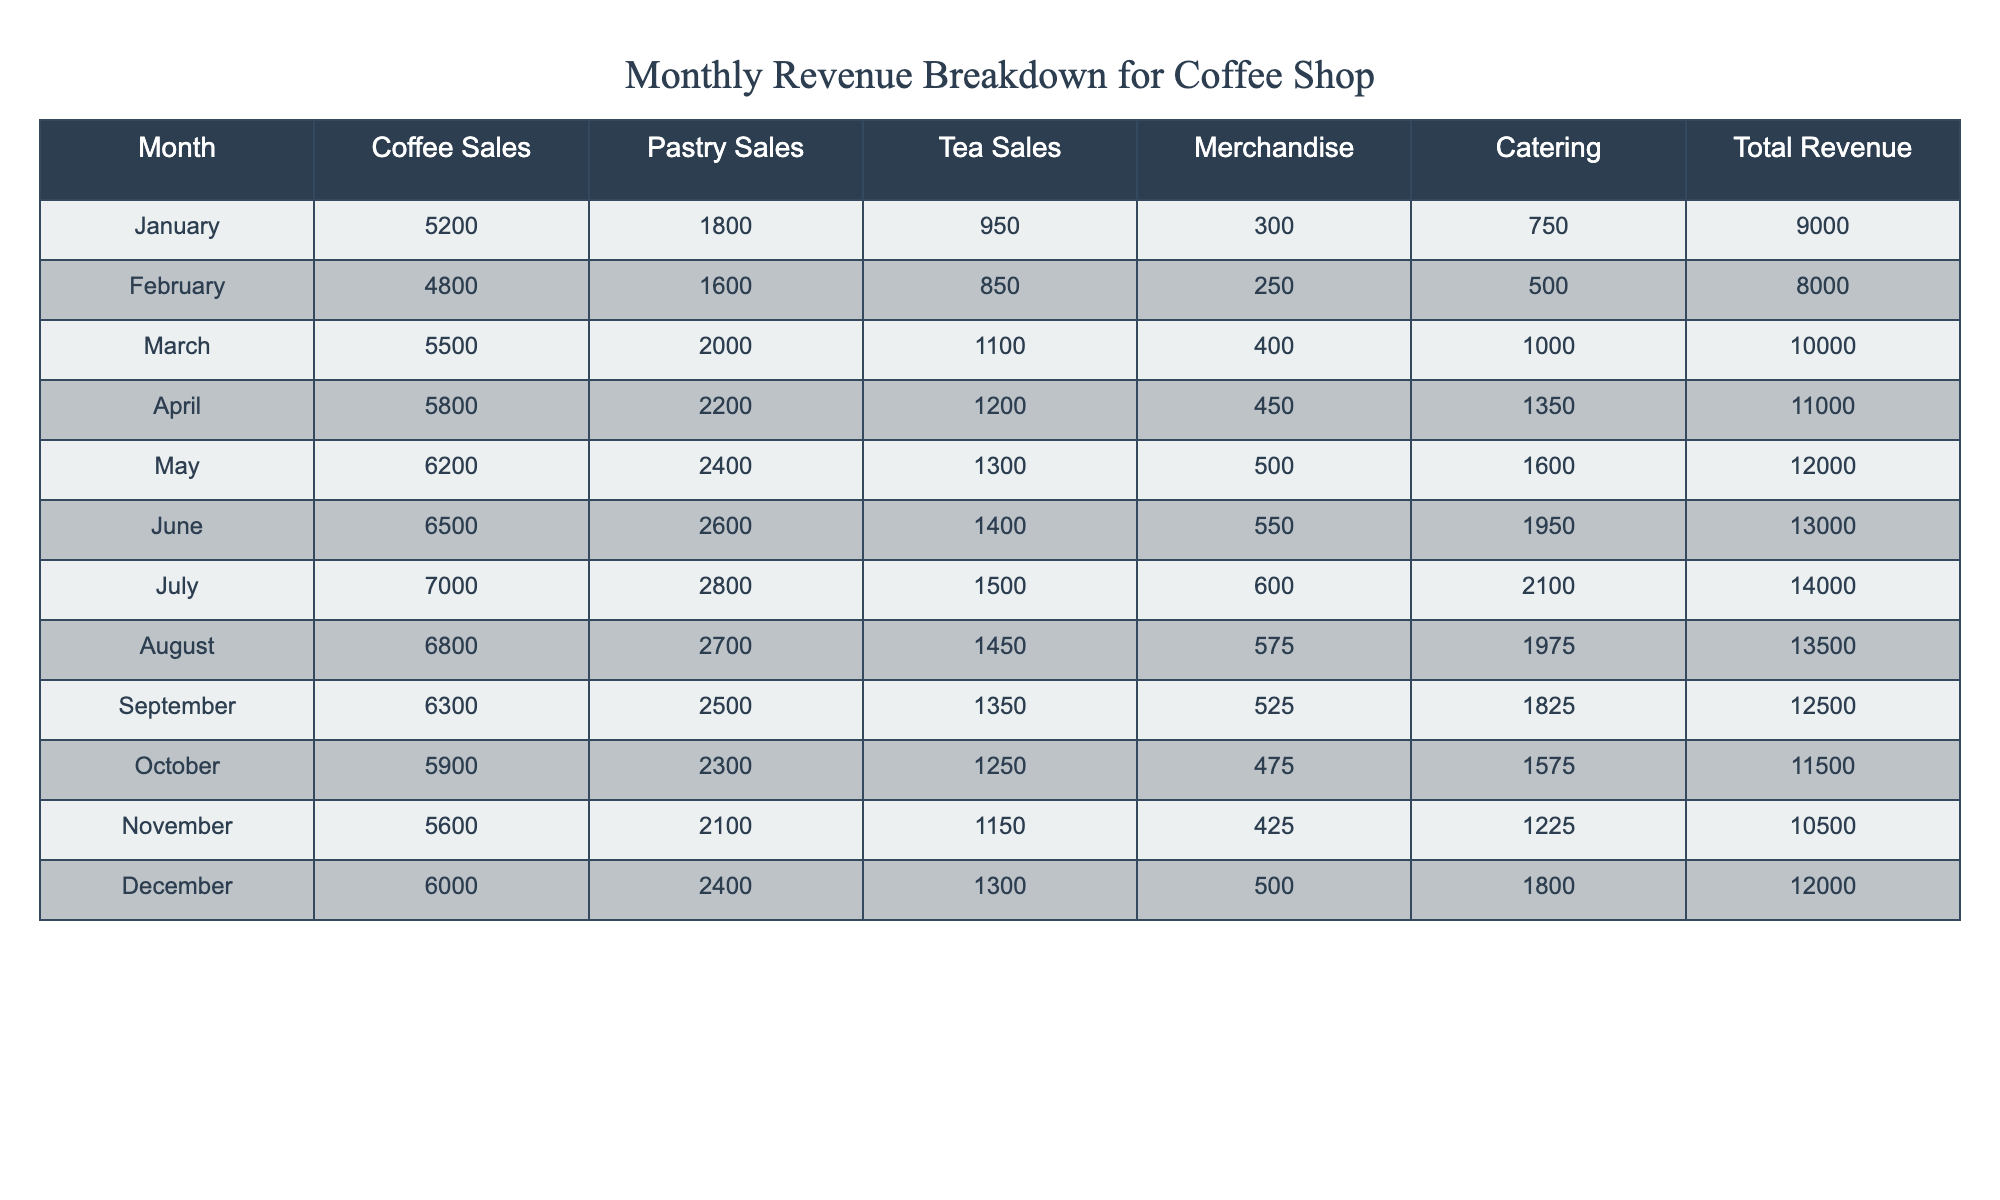What was the total revenue in July? The table shows that the total revenue for July is listed directly under the 'Total Revenue' column, which is 14,000.
Answer: 14,000 What were the coffee sales in March? The coffee sales figure for March can be found directly in the 'Coffee Sales' column under March, which is 5,500.
Answer: 5,500 Which month had the highest pastry sales? By comparing the values in the 'Pastry Sales' column, April has the highest sales at 2,200.
Answer: April What is the total revenue for the first half of the year (January to June)? To calculate this, sum the total revenues from January to June: 9,000 + 8,000 + 10,000 + 11,000 + 12,000 + 13,000 = 63,000.
Answer: 63,000 Did the coffee shop earn more in December than in January? Comparing the total revenues of December (12,000) and January (9,000), December's revenue is higher.
Answer: Yes What are the average tea sales over the year? Add the tea sales figures for each month (950 + 850 + 1,100 + 1,200 + 1,300 + 1,400 + 1,500 + 1,450 + 1,350 + 1,250 + 1,150 + 1,300 = 15,800) and divide by 12 months to get 15,800 / 12 = 1,316.67.
Answer: 1,316.67 In which month did catering sales reach 1,000 or more? By reviewing the 'Catering' column, catering sales reached 1,000 or more in March, April, May, June, July, August, and December.
Answer: Multiple months What is the difference in total revenue between June and October? Calculate the total revenue for June (13,000) and October (11,500) and find their difference: 13,000 - 11,500 = 1,500.
Answer: 1,500 What was the merchandise sales for September? The 'Merchandise' column shows September's sales as 525.
Answer: 525 Did the coffee shop have a consistent growth in total revenue every month? By examining the 'Total Revenue' column, it shows fluctuations in revenue, indicating that there was not consistent growth every month.
Answer: No 